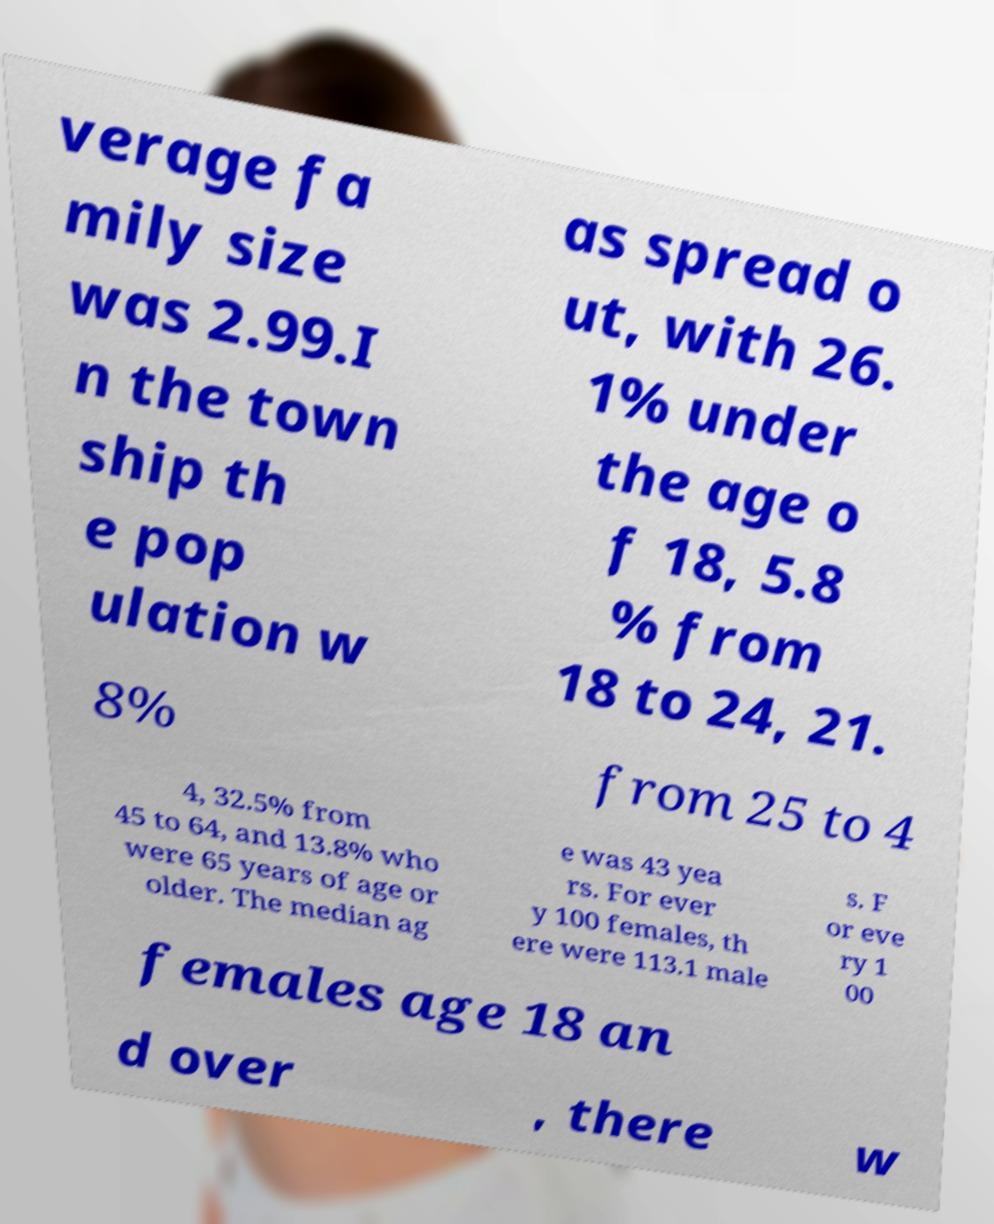Please identify and transcribe the text found in this image. verage fa mily size was 2.99.I n the town ship th e pop ulation w as spread o ut, with 26. 1% under the age o f 18, 5.8 % from 18 to 24, 21. 8% from 25 to 4 4, 32.5% from 45 to 64, and 13.8% who were 65 years of age or older. The median ag e was 43 yea rs. For ever y 100 females, th ere were 113.1 male s. F or eve ry 1 00 females age 18 an d over , there w 